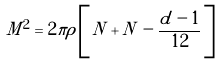Convert formula to latex. <formula><loc_0><loc_0><loc_500><loc_500>M ^ { 2 } = 2 \pi \rho \left [ \, N + \tilde { N } \, - \frac { d - 1 } { 1 2 } \, \right ]</formula> 